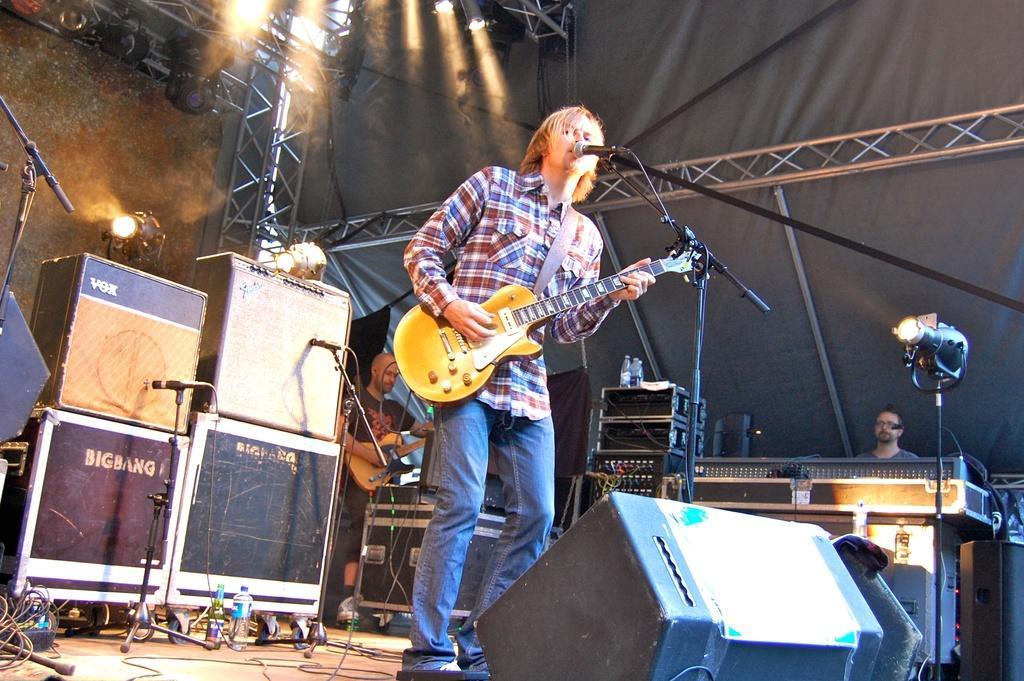Could you give a brief overview of what you see in this image? This image is clicked in a concert. There are three men in this image. In the front, the man is playing guitar and singing in the mic. In the front, there is a speaker. In the background, there are boxes, mics, stands and wall. 